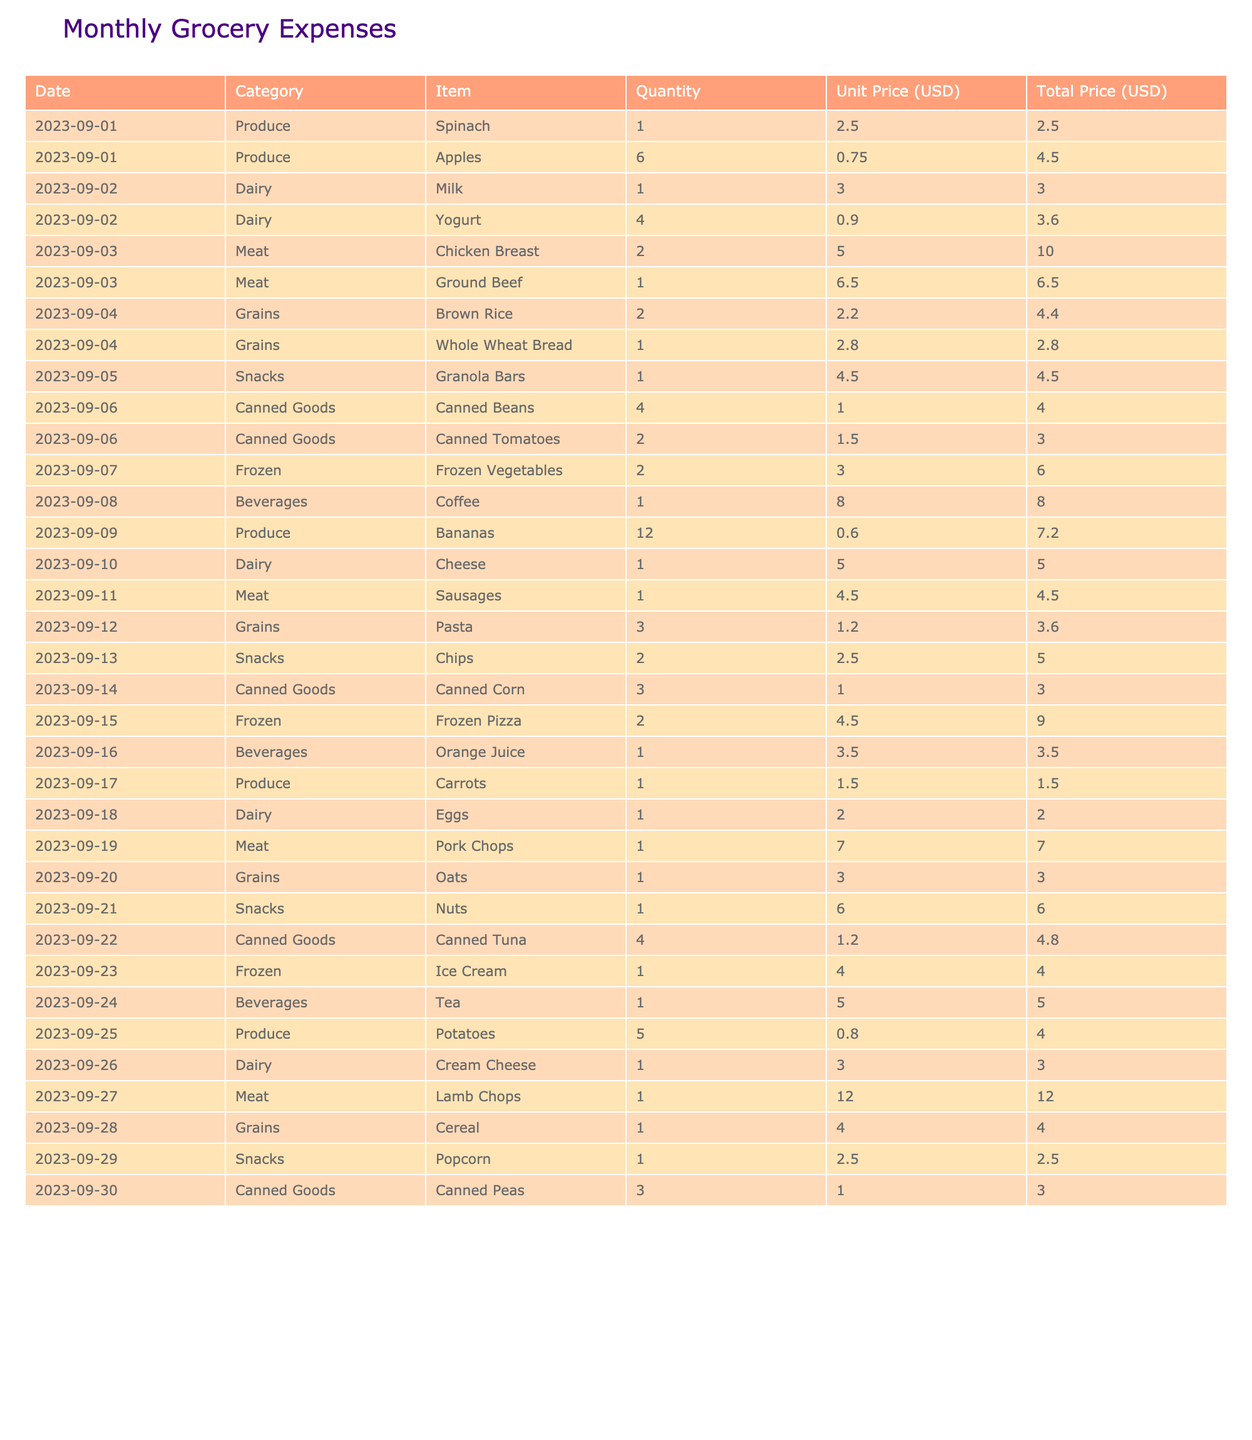What was the total cost of dairy products for the month? To find the total cost of dairy products, I add the total prices: Milk ($3.00) + Yogurt ($3.60) + Cheese ($5.00) + Eggs ($2.00) + Cream Cheese ($3.00) = $16.60
Answer: $16.60 How many total items did we purchase from the produce category? I count the items in the produce category: Spinach (1), Apples (6), Bananas (12), Carrots (1), Potatoes (5) = 1 + 6 + 12 + 1 + 5 = 25
Answer: 25 Did we spend more on snacks or canned goods? I will compare the total costs: Snacks are $4.50 (Granola Bars) + $5.00 (Chips) + $6.00 (Nuts) + $2.50 (Popcorn) = $18.00. Canned Goods are $4.00 (Canned Beans) + $3.00 (Canned Tomatoes) + $3.00 (Canned Corn) + $4.80 (Canned Tuna) + $3.00 (Canned Peas) = $17.80. Since $18.00 is greater than $17.80, we spent more on snacks.
Answer: Yes What is the average price of meat items purchased during the month? First, I find the total cost of meat: Chicken Breast ($10.00) + Ground Beef ($6.50) + Sausages ($4.50) + Pork Chops ($7.00) + Lamb Chops ($12.00) = $40.00. There are 5 meat items, so the average price is $40.00 / 5 = $8.00
Answer: $8.00 Which category had the highest total expenditure? I will sum the total costs for each category: Produce ($19.70), Dairy ($16.60), Meat ($40.00), Grains ($19.80), Snacks ($18.00), Canned Goods ($17.80), Frozen ($19.00), Beverages ($16.50). The highest expenditure is in the Meat category.
Answer: Meat If we had a budget of $150 for the month, did we stay within that budget? To find out, I calculate the total costs: Produce ($19.70) + Dairy ($16.60) + Meat ($40.00) + Grains ($19.80) + Snacks ($18.00) + Canned Goods ($17.80) + Frozen ($19.00) + Beverages ($16.50) = $166.60. Since $166.60 exceeds $150, we did not stay within budget.
Answer: No What was the total spent on frozen items? I sum the prices of frozen items: Frozen Vegetables ($6.00) + Frozen Pizza ($9.00) + Ice Cream ($4.00) = $19.00
Answer: $19.00 How many more units of snacks did we purchase than grains? Total units of snacks: Granola Bars (1) + Chips (2) + Nuts (1) + Popcorn (1) = 5. Total units of grains: Brown Rice (2) + Whole Wheat Bread (1) + Pasta (3) + Oats (1) + Cereal (1) = 8. The difference is 5 - 8 = -3, indicating fewer snacks than grains.
Answer: -3 Which day did we spend the most on a single food item? I will look through the total prices for each entry: the highest amount is Lamb Chops on 2023-09-27 for $12.00.
Answer: September 27 What's the total expenditure on beverages? I add the costs of beverages: Coffee ($8.00) + Orange Juice ($3.50) + Tea ($5.00) = $16.50
Answer: $16.50 